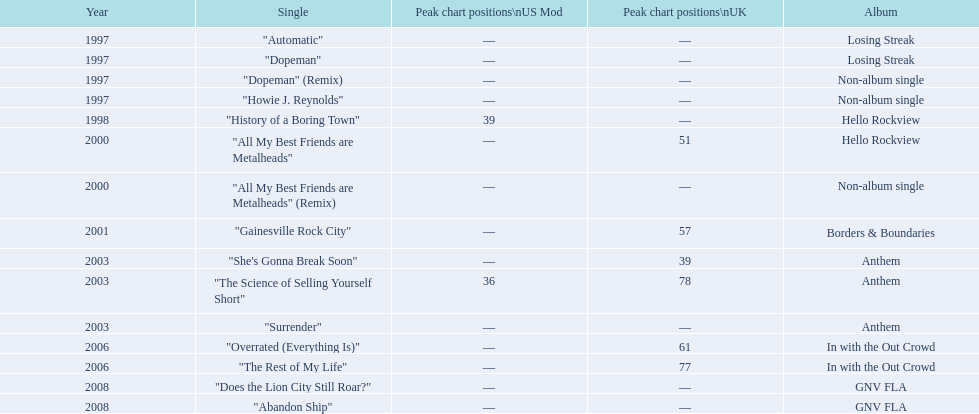How many years passed between the release of losing streak album and gnv fla? 11. 